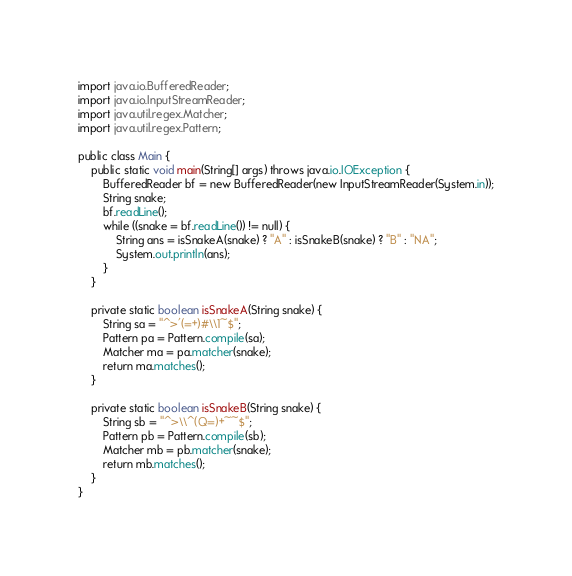<code> <loc_0><loc_0><loc_500><loc_500><_Java_>import java.io.BufferedReader;
import java.io.InputStreamReader;
import java.util.regex.Matcher;
import java.util.regex.Pattern;

public class Main {
	public static void main(String[] args) throws java.io.IOException {
		BufferedReader bf = new BufferedReader(new InputStreamReader(System.in));
		String snake;
		bf.readLine();
		while ((snake = bf.readLine()) != null) {
			String ans = isSnakeA(snake) ? "A" : isSnakeB(snake) ? "B" : "NA";
			System.out.println(ans);
		}
	}

	private static boolean isSnakeA(String snake) {
		String sa = "^>'(=+)#\\1~$";
		Pattern pa = Pattern.compile(sa);
		Matcher ma = pa.matcher(snake);
		return ma.matches();
	}

	private static boolean isSnakeB(String snake) {
		String sb = "^>\\^(Q=)+~~$";
		Pattern pb = Pattern.compile(sb);
		Matcher mb = pb.matcher(snake);
		return mb.matches();
	}
}</code> 